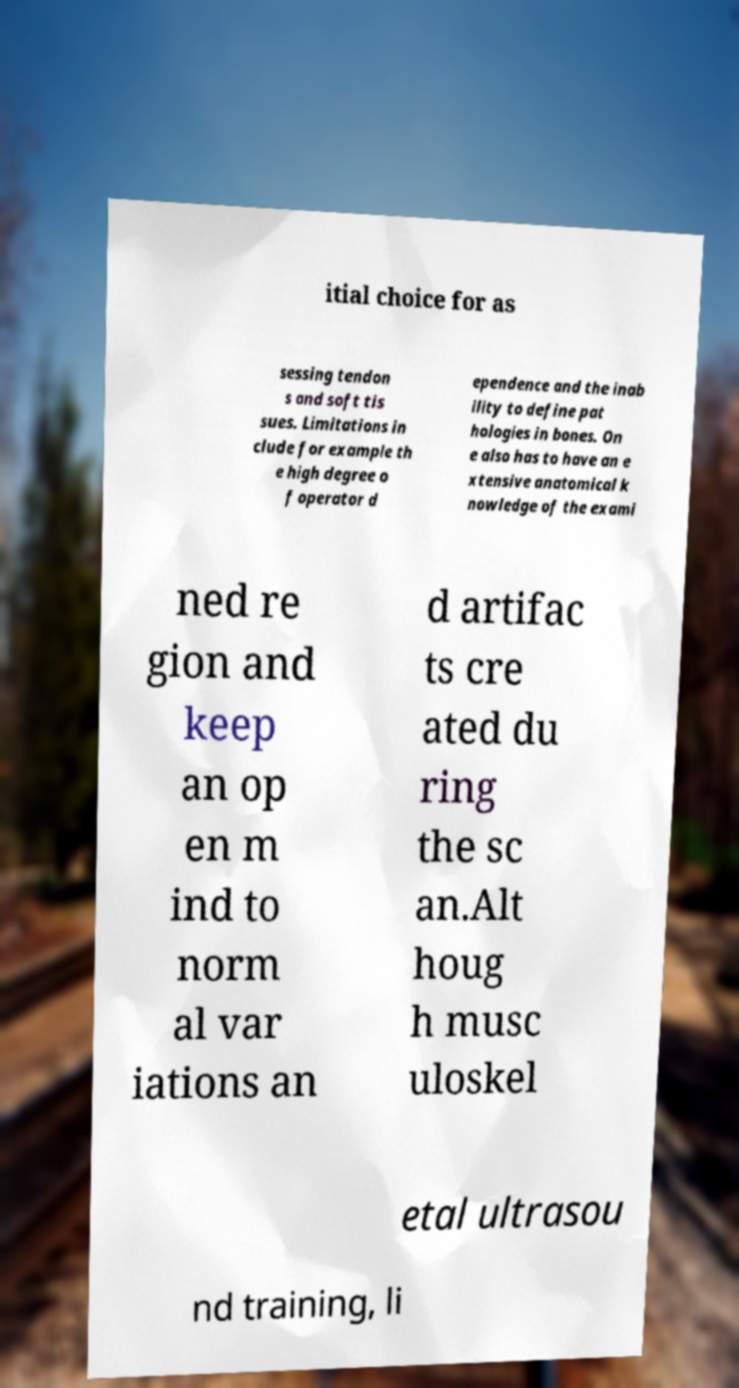For documentation purposes, I need the text within this image transcribed. Could you provide that? itial choice for as sessing tendon s and soft tis sues. Limitations in clude for example th e high degree o f operator d ependence and the inab ility to define pat hologies in bones. On e also has to have an e xtensive anatomical k nowledge of the exami ned re gion and keep an op en m ind to norm al var iations an d artifac ts cre ated du ring the sc an.Alt houg h musc uloskel etal ultrasou nd training, li 